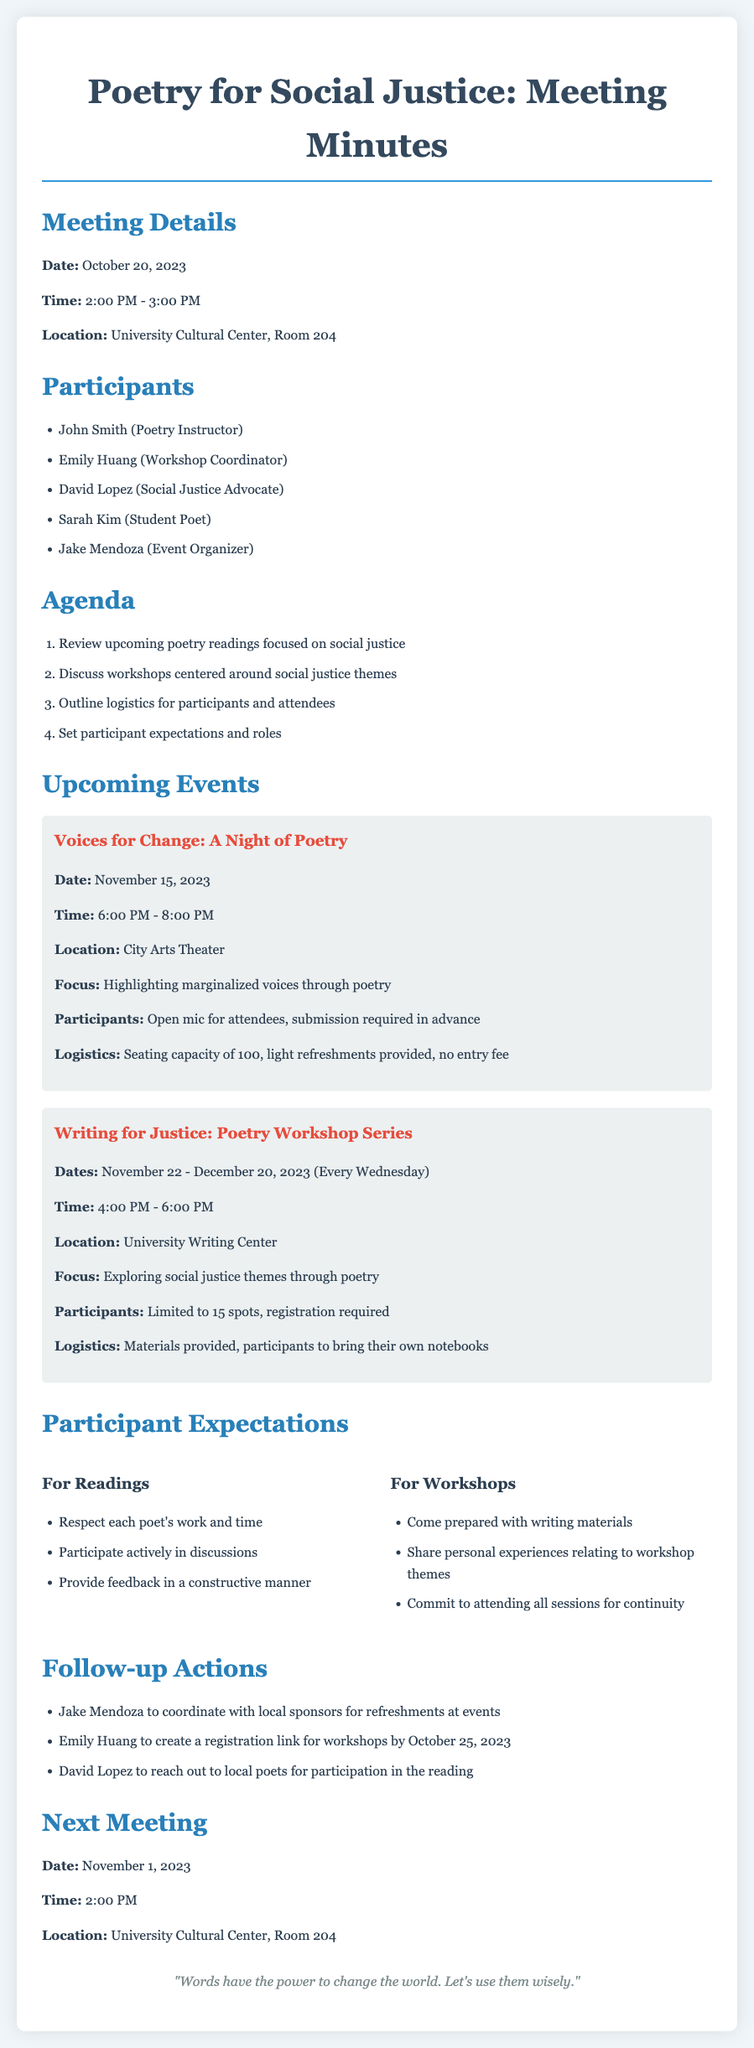What is the date of the next meeting? The next meeting date is mentioned in the document under "Next Meeting."
Answer: November 1, 2023 Who is the workshop coordinator? The name of the workshop coordinator is listed under "Participants."
Answer: Emily Huang What is the location for the "Voices for Change" event? The location is specified in the "Upcoming Events" section for that event.
Answer: City Arts Theater How many spots are available for the "Writing for Justice" workshop? The number of spots is detailed under the "Participants" section for the workshop event.
Answer: 15 spots What is the main focus of the workshops? The focus of the workshops is outlined in the "Focus" section of the workshop event description.
Answer: Exploring social justice themes through poetry What is required for participation in the open mic at "Voices for Change"? The requirements for the open mic are listed in the "Participants" section for that event.
Answer: Submission required in advance What should participants bring to the workshops? The document specifies what participants need to bring in the "Logistics" section for the workshop event.
Answer: Their own notebooks Who is responsible for coordinating with local sponsors? This person's responsibility is described in the "Follow-up Actions" section.
Answer: Jake Mendoza What is the time for the "Writing for Justice" workshops? The time for the workshops is indicated in the "Time" section of the event details.
Answer: 4:00 PM - 6:00 PM 